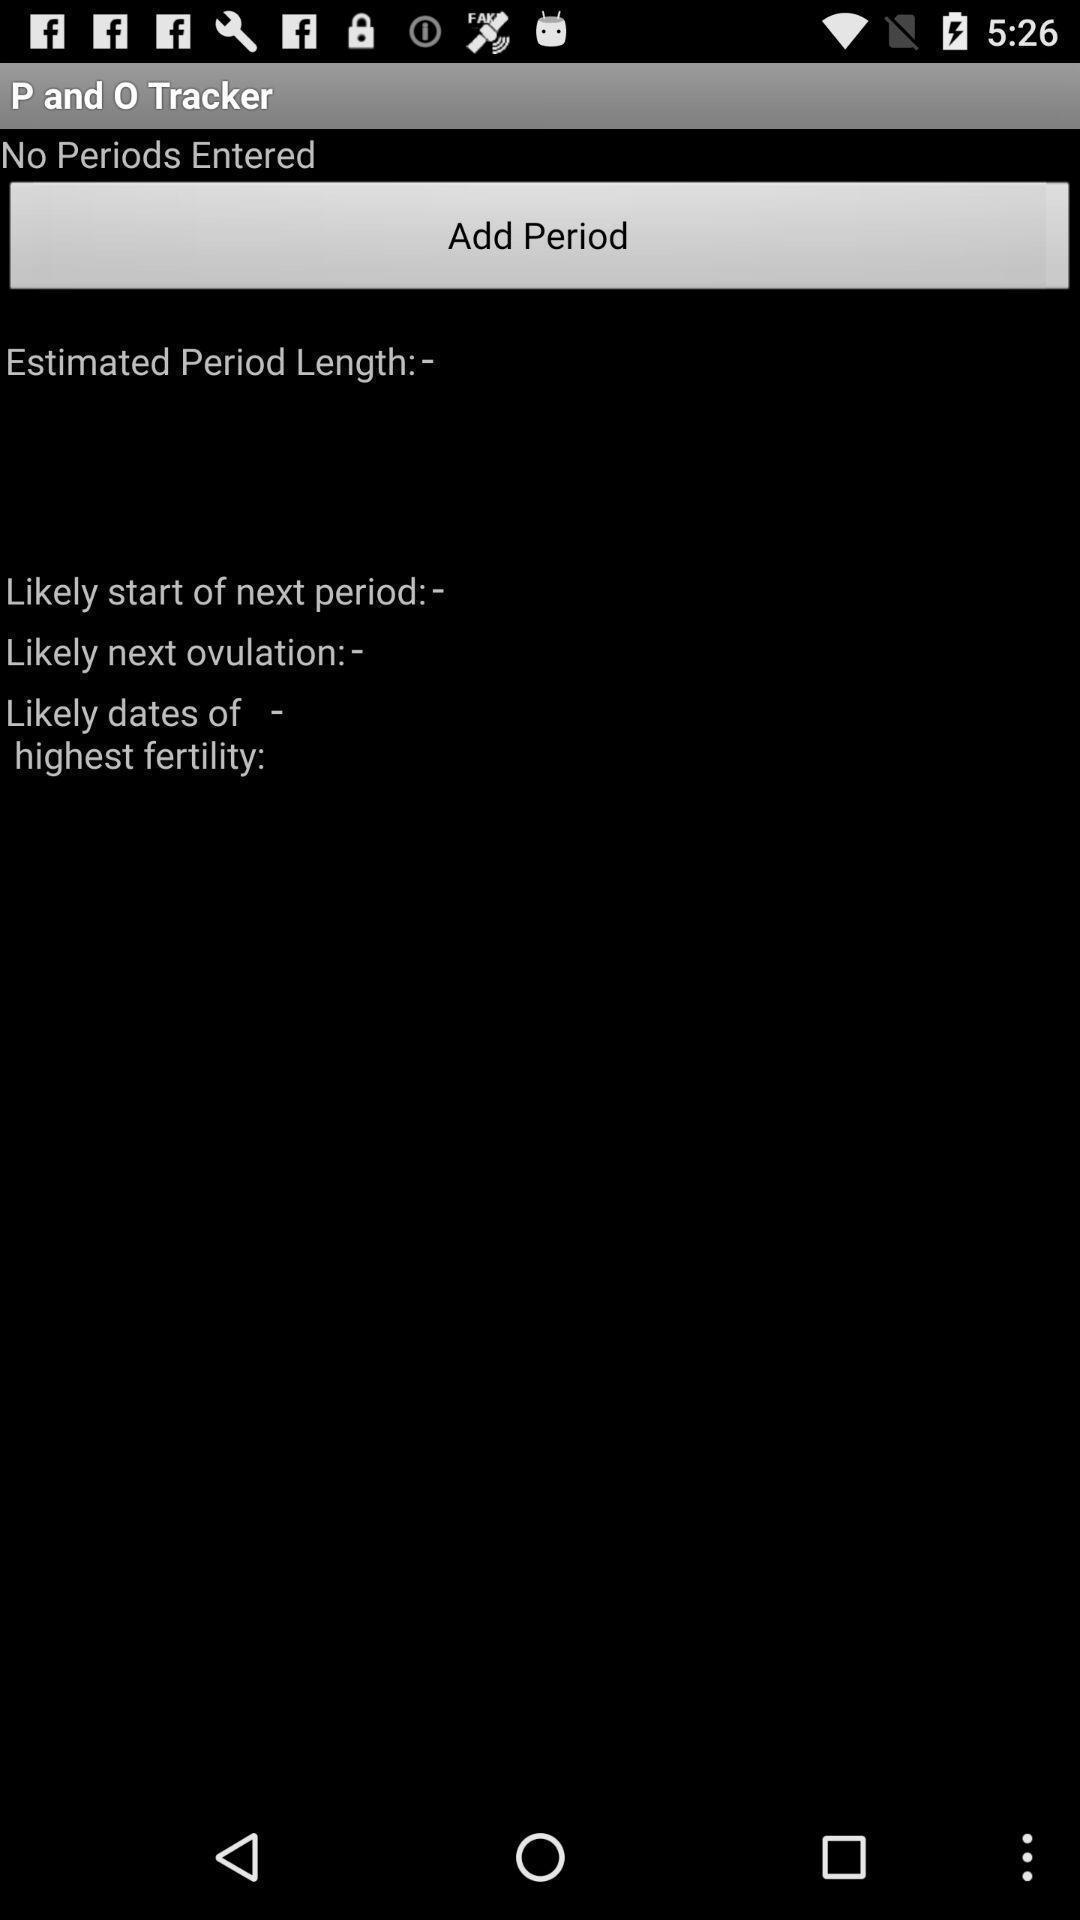Explain the elements present in this screenshot. Screen displaying period tracker page. 